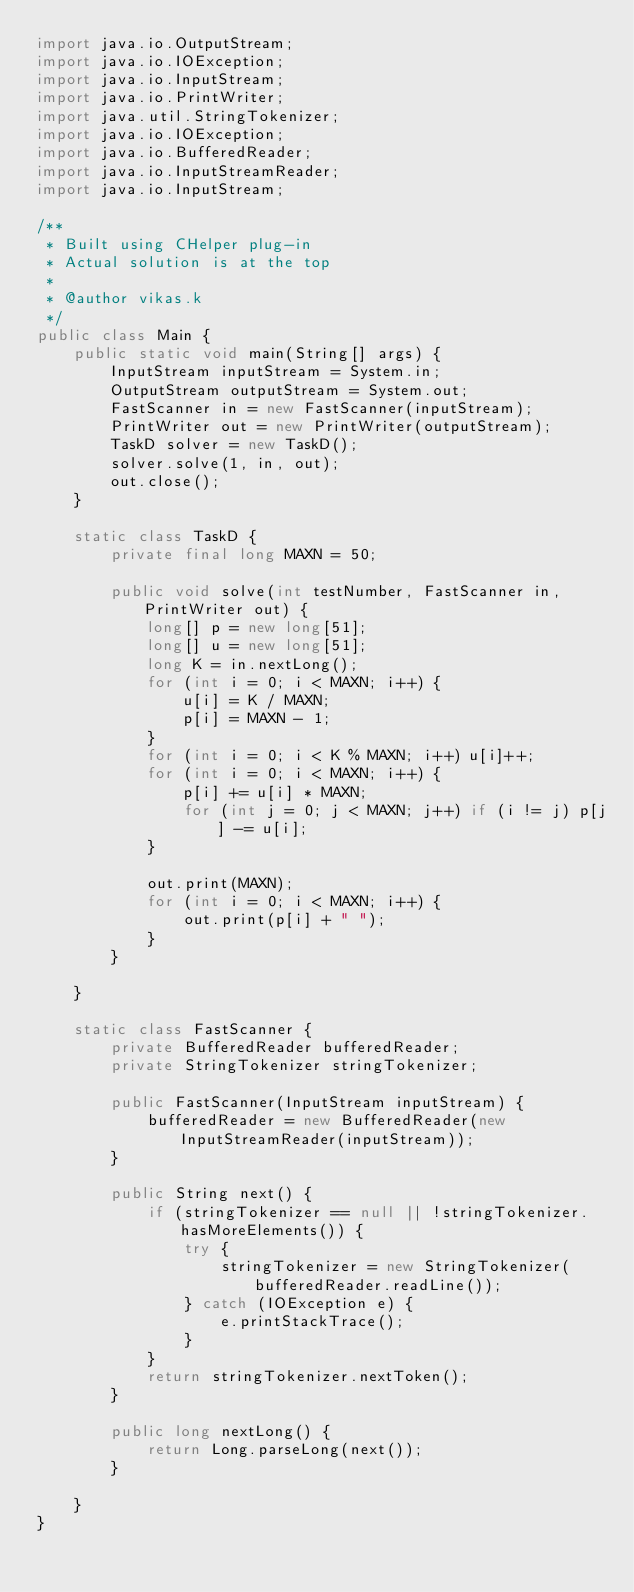<code> <loc_0><loc_0><loc_500><loc_500><_Java_>import java.io.OutputStream;
import java.io.IOException;
import java.io.InputStream;
import java.io.PrintWriter;
import java.util.StringTokenizer;
import java.io.IOException;
import java.io.BufferedReader;
import java.io.InputStreamReader;
import java.io.InputStream;

/**
 * Built using CHelper plug-in
 * Actual solution is at the top
 *
 * @author vikas.k
 */
public class Main {
    public static void main(String[] args) {
        InputStream inputStream = System.in;
        OutputStream outputStream = System.out;
        FastScanner in = new FastScanner(inputStream);
        PrintWriter out = new PrintWriter(outputStream);
        TaskD solver = new TaskD();
        solver.solve(1, in, out);
        out.close();
    }

    static class TaskD {
        private final long MAXN = 50;

        public void solve(int testNumber, FastScanner in, PrintWriter out) {
            long[] p = new long[51];
            long[] u = new long[51];
            long K = in.nextLong();
            for (int i = 0; i < MAXN; i++) {
                u[i] = K / MAXN;
                p[i] = MAXN - 1;
            }
            for (int i = 0; i < K % MAXN; i++) u[i]++;
            for (int i = 0; i < MAXN; i++) {
                p[i] += u[i] * MAXN;
                for (int j = 0; j < MAXN; j++) if (i != j) p[j] -= u[i];
            }

            out.print(MAXN);
            for (int i = 0; i < MAXN; i++) {
                out.print(p[i] + " ");
            }
        }

    }

    static class FastScanner {
        private BufferedReader bufferedReader;
        private StringTokenizer stringTokenizer;

        public FastScanner(InputStream inputStream) {
            bufferedReader = new BufferedReader(new InputStreamReader(inputStream));
        }

        public String next() {
            if (stringTokenizer == null || !stringTokenizer.hasMoreElements()) {
                try {
                    stringTokenizer = new StringTokenizer(bufferedReader.readLine());
                } catch (IOException e) {
                    e.printStackTrace();
                }
            }
            return stringTokenizer.nextToken();
        }

        public long nextLong() {
            return Long.parseLong(next());
        }

    }
}

</code> 